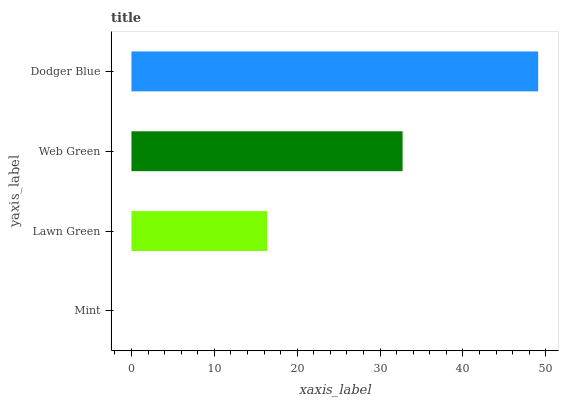Is Mint the minimum?
Answer yes or no. Yes. Is Dodger Blue the maximum?
Answer yes or no. Yes. Is Lawn Green the minimum?
Answer yes or no. No. Is Lawn Green the maximum?
Answer yes or no. No. Is Lawn Green greater than Mint?
Answer yes or no. Yes. Is Mint less than Lawn Green?
Answer yes or no. Yes. Is Mint greater than Lawn Green?
Answer yes or no. No. Is Lawn Green less than Mint?
Answer yes or no. No. Is Web Green the high median?
Answer yes or no. Yes. Is Lawn Green the low median?
Answer yes or no. Yes. Is Dodger Blue the high median?
Answer yes or no. No. Is Web Green the low median?
Answer yes or no. No. 